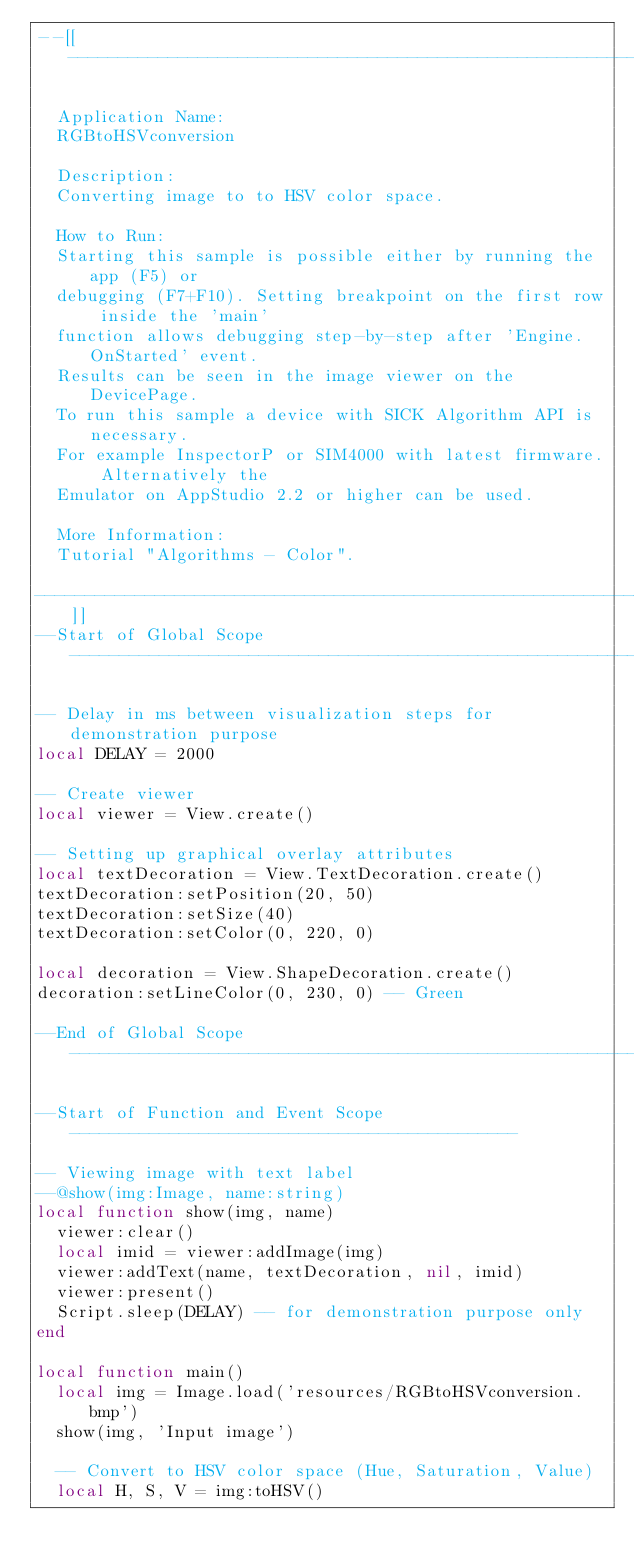Convert code to text. <code><loc_0><loc_0><loc_500><loc_500><_Lua_>--[[----------------------------------------------------------------------------

  Application Name:
  RGBtoHSVconversion
                                                                                             
  Description:
  Converting image to to HSV color space.
  
  How to Run:
  Starting this sample is possible either by running the app (F5) or
  debugging (F7+F10). Setting breakpoint on the first row inside the 'main'
  function allows debugging step-by-step after 'Engine.OnStarted' event.
  Results can be seen in the image viewer on the DevicePage.
  To run this sample a device with SICK Algorithm API is necessary.
  For example InspectorP or SIM4000 with latest firmware. Alternatively the
  Emulator on AppStudio 2.2 or higher can be used.
       
  More Information:
  Tutorial "Algorithms - Color".

------------------------------------------------------------------------------]]
--Start of Global Scope---------------------------------------------------------

-- Delay in ms between visualization steps for demonstration purpose
local DELAY = 2000

-- Create viewer
local viewer = View.create()

-- Setting up graphical overlay attributes
local textDecoration = View.TextDecoration.create()
textDecoration:setPosition(20, 50)
textDecoration:setSize(40)
textDecoration:setColor(0, 220, 0)

local decoration = View.ShapeDecoration.create()
decoration:setLineColor(0, 230, 0) -- Green

--End of Global Scope-----------------------------------------------------------

--Start of Function and Event Scope---------------------------------------------

-- Viewing image with text label
--@show(img:Image, name:string)
local function show(img, name)
  viewer:clear()
  local imid = viewer:addImage(img)
  viewer:addText(name, textDecoration, nil, imid)
  viewer:present()
  Script.sleep(DELAY) -- for demonstration purpose only
end

local function main()
  local img = Image.load('resources/RGBtoHSVconversion.bmp')
  show(img, 'Input image')

  -- Convert to HSV color space (Hue, Saturation, Value)
  local H, S, V = img:toHSV()</code> 